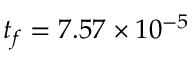<formula> <loc_0><loc_0><loc_500><loc_500>t _ { f } = 7 . 5 7 \times 1 0 ^ { - 5 }</formula> 